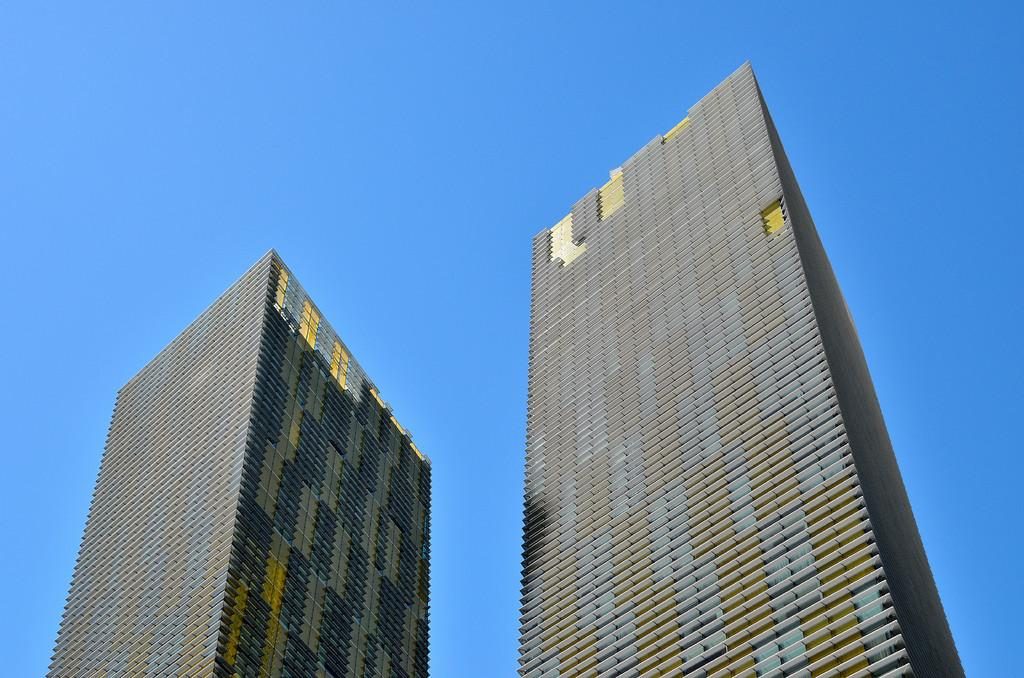How many buildings can be seen in the image? There are two buildings in the image. What is visible in the background of the image? The sky is visible in the background of the image. What type of beast can be seen swimming in the waves in the image? There is no beast or waves present in the image; it features two buildings and a sky background. 